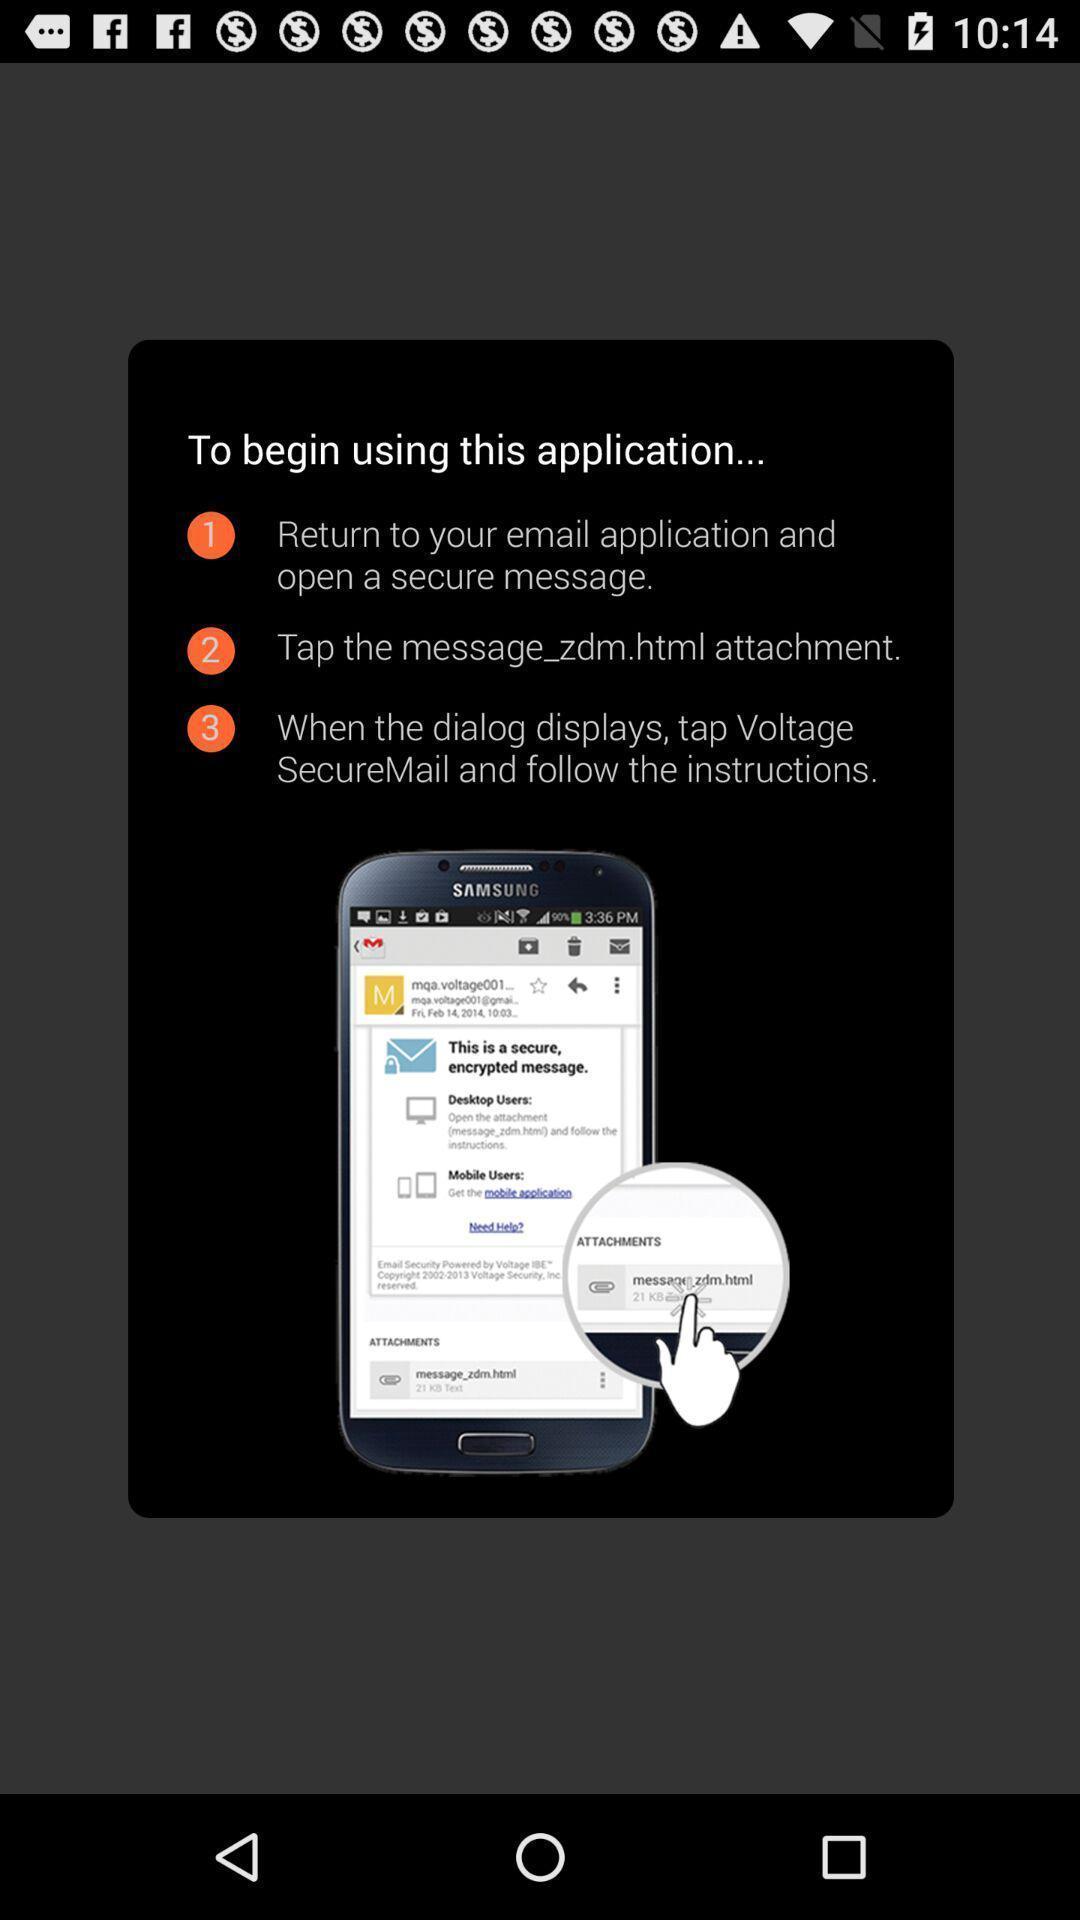Explain what's happening in this screen capture. Pop-up showing steps to begin application. 